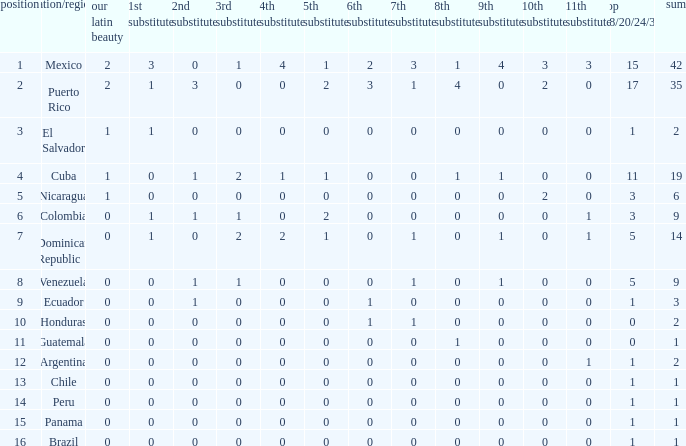What is the average total of the country with a 4th runner-up of 0 and a Nuestra Bellaza Latina less than 0? None. 